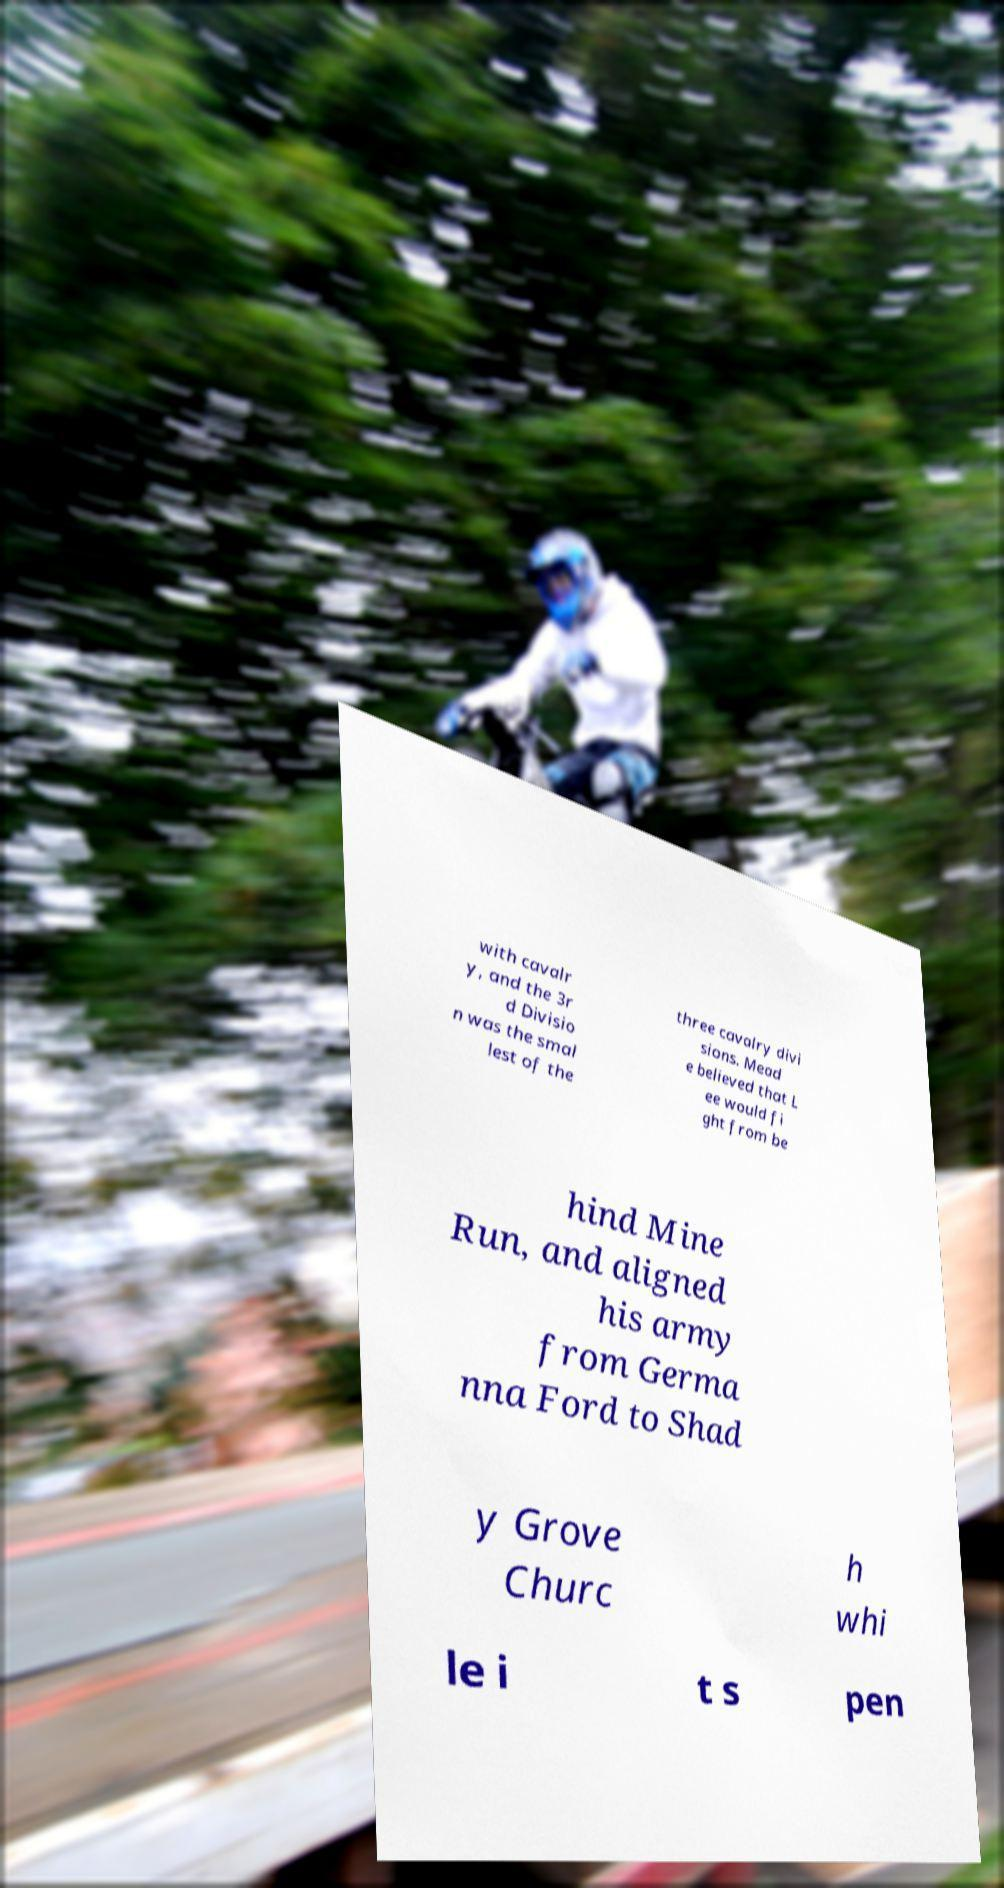Could you extract and type out the text from this image? with cavalr y, and the 3r d Divisio n was the smal lest of the three cavalry divi sions. Mead e believed that L ee would fi ght from be hind Mine Run, and aligned his army from Germa nna Ford to Shad y Grove Churc h whi le i t s pen 